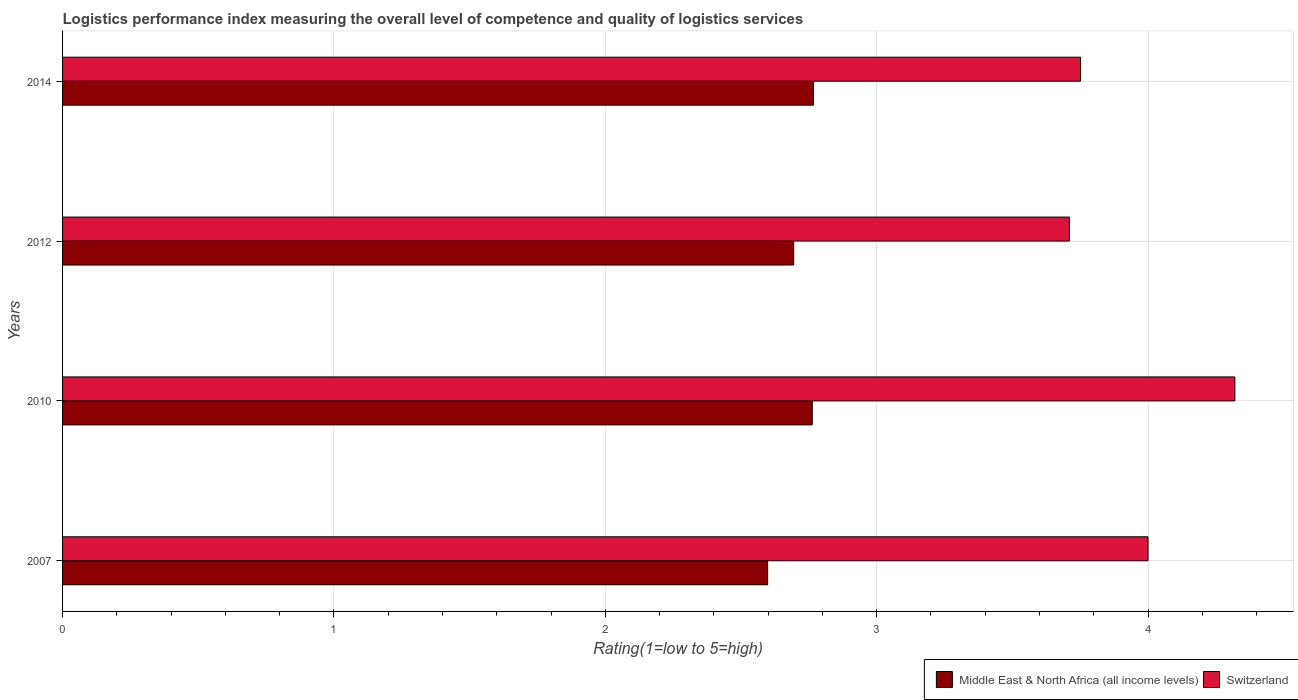Are the number of bars per tick equal to the number of legend labels?
Your answer should be compact. Yes. How many bars are there on the 3rd tick from the top?
Keep it short and to the point. 2. How many bars are there on the 3rd tick from the bottom?
Your response must be concise. 2. What is the label of the 2nd group of bars from the top?
Give a very brief answer. 2012. What is the Logistic performance index in Middle East & North Africa (all income levels) in 2010?
Provide a succinct answer. 2.76. Across all years, what is the maximum Logistic performance index in Switzerland?
Give a very brief answer. 4.32. Across all years, what is the minimum Logistic performance index in Switzerland?
Make the answer very short. 3.71. What is the total Logistic performance index in Switzerland in the graph?
Keep it short and to the point. 15.78. What is the difference between the Logistic performance index in Switzerland in 2007 and that in 2014?
Your response must be concise. 0.25. What is the difference between the Logistic performance index in Middle East & North Africa (all income levels) in 2014 and the Logistic performance index in Switzerland in 2007?
Provide a short and direct response. -1.23. What is the average Logistic performance index in Switzerland per year?
Offer a terse response. 3.95. In the year 2012, what is the difference between the Logistic performance index in Middle East & North Africa (all income levels) and Logistic performance index in Switzerland?
Give a very brief answer. -1.02. What is the ratio of the Logistic performance index in Middle East & North Africa (all income levels) in 2010 to that in 2012?
Give a very brief answer. 1.03. Is the difference between the Logistic performance index in Middle East & North Africa (all income levels) in 2007 and 2012 greater than the difference between the Logistic performance index in Switzerland in 2007 and 2012?
Offer a very short reply. No. What is the difference between the highest and the second highest Logistic performance index in Switzerland?
Offer a terse response. 0.32. What is the difference between the highest and the lowest Logistic performance index in Middle East & North Africa (all income levels)?
Offer a terse response. 0.17. Is the sum of the Logistic performance index in Middle East & North Africa (all income levels) in 2007 and 2012 greater than the maximum Logistic performance index in Switzerland across all years?
Provide a short and direct response. Yes. What does the 1st bar from the top in 2010 represents?
Make the answer very short. Switzerland. What does the 1st bar from the bottom in 2010 represents?
Ensure brevity in your answer.  Middle East & North Africa (all income levels). How many bars are there?
Offer a very short reply. 8. What is the difference between two consecutive major ticks on the X-axis?
Keep it short and to the point. 1. Are the values on the major ticks of X-axis written in scientific E-notation?
Give a very brief answer. No. Does the graph contain grids?
Keep it short and to the point. Yes. How many legend labels are there?
Ensure brevity in your answer.  2. How are the legend labels stacked?
Ensure brevity in your answer.  Horizontal. What is the title of the graph?
Make the answer very short. Logistics performance index measuring the overall level of competence and quality of logistics services. Does "Panama" appear as one of the legend labels in the graph?
Keep it short and to the point. No. What is the label or title of the X-axis?
Provide a succinct answer. Rating(1=low to 5=high). What is the Rating(1=low to 5=high) of Middle East & North Africa (all income levels) in 2007?
Keep it short and to the point. 2.6. What is the Rating(1=low to 5=high) of Middle East & North Africa (all income levels) in 2010?
Provide a short and direct response. 2.76. What is the Rating(1=low to 5=high) of Switzerland in 2010?
Keep it short and to the point. 4.32. What is the Rating(1=low to 5=high) of Middle East & North Africa (all income levels) in 2012?
Offer a very short reply. 2.69. What is the Rating(1=low to 5=high) in Switzerland in 2012?
Keep it short and to the point. 3.71. What is the Rating(1=low to 5=high) of Middle East & North Africa (all income levels) in 2014?
Make the answer very short. 2.77. What is the Rating(1=low to 5=high) in Switzerland in 2014?
Offer a terse response. 3.75. Across all years, what is the maximum Rating(1=low to 5=high) of Middle East & North Africa (all income levels)?
Your answer should be very brief. 2.77. Across all years, what is the maximum Rating(1=low to 5=high) of Switzerland?
Give a very brief answer. 4.32. Across all years, what is the minimum Rating(1=low to 5=high) of Middle East & North Africa (all income levels)?
Provide a succinct answer. 2.6. Across all years, what is the minimum Rating(1=low to 5=high) of Switzerland?
Your answer should be very brief. 3.71. What is the total Rating(1=low to 5=high) in Middle East & North Africa (all income levels) in the graph?
Offer a terse response. 10.82. What is the total Rating(1=low to 5=high) of Switzerland in the graph?
Your answer should be compact. 15.78. What is the difference between the Rating(1=low to 5=high) of Middle East & North Africa (all income levels) in 2007 and that in 2010?
Ensure brevity in your answer.  -0.16. What is the difference between the Rating(1=low to 5=high) of Switzerland in 2007 and that in 2010?
Offer a terse response. -0.32. What is the difference between the Rating(1=low to 5=high) of Middle East & North Africa (all income levels) in 2007 and that in 2012?
Offer a very short reply. -0.1. What is the difference between the Rating(1=low to 5=high) of Switzerland in 2007 and that in 2012?
Your answer should be compact. 0.29. What is the difference between the Rating(1=low to 5=high) of Middle East & North Africa (all income levels) in 2007 and that in 2014?
Provide a short and direct response. -0.17. What is the difference between the Rating(1=low to 5=high) in Switzerland in 2007 and that in 2014?
Provide a succinct answer. 0.25. What is the difference between the Rating(1=low to 5=high) in Middle East & North Africa (all income levels) in 2010 and that in 2012?
Your response must be concise. 0.07. What is the difference between the Rating(1=low to 5=high) of Switzerland in 2010 and that in 2012?
Your response must be concise. 0.61. What is the difference between the Rating(1=low to 5=high) of Middle East & North Africa (all income levels) in 2010 and that in 2014?
Your answer should be very brief. -0. What is the difference between the Rating(1=low to 5=high) of Switzerland in 2010 and that in 2014?
Ensure brevity in your answer.  0.57. What is the difference between the Rating(1=low to 5=high) in Middle East & North Africa (all income levels) in 2012 and that in 2014?
Offer a terse response. -0.07. What is the difference between the Rating(1=low to 5=high) of Switzerland in 2012 and that in 2014?
Provide a short and direct response. -0.04. What is the difference between the Rating(1=low to 5=high) of Middle East & North Africa (all income levels) in 2007 and the Rating(1=low to 5=high) of Switzerland in 2010?
Offer a very short reply. -1.72. What is the difference between the Rating(1=low to 5=high) in Middle East & North Africa (all income levels) in 2007 and the Rating(1=low to 5=high) in Switzerland in 2012?
Keep it short and to the point. -1.11. What is the difference between the Rating(1=low to 5=high) in Middle East & North Africa (all income levels) in 2007 and the Rating(1=low to 5=high) in Switzerland in 2014?
Offer a very short reply. -1.15. What is the difference between the Rating(1=low to 5=high) in Middle East & North Africa (all income levels) in 2010 and the Rating(1=low to 5=high) in Switzerland in 2012?
Keep it short and to the point. -0.95. What is the difference between the Rating(1=low to 5=high) of Middle East & North Africa (all income levels) in 2010 and the Rating(1=low to 5=high) of Switzerland in 2014?
Make the answer very short. -0.99. What is the difference between the Rating(1=low to 5=high) of Middle East & North Africa (all income levels) in 2012 and the Rating(1=low to 5=high) of Switzerland in 2014?
Provide a succinct answer. -1.06. What is the average Rating(1=low to 5=high) of Middle East & North Africa (all income levels) per year?
Give a very brief answer. 2.71. What is the average Rating(1=low to 5=high) of Switzerland per year?
Ensure brevity in your answer.  3.95. In the year 2007, what is the difference between the Rating(1=low to 5=high) of Middle East & North Africa (all income levels) and Rating(1=low to 5=high) of Switzerland?
Your response must be concise. -1.4. In the year 2010, what is the difference between the Rating(1=low to 5=high) of Middle East & North Africa (all income levels) and Rating(1=low to 5=high) of Switzerland?
Your answer should be compact. -1.56. In the year 2012, what is the difference between the Rating(1=low to 5=high) in Middle East & North Africa (all income levels) and Rating(1=low to 5=high) in Switzerland?
Give a very brief answer. -1.02. In the year 2014, what is the difference between the Rating(1=low to 5=high) of Middle East & North Africa (all income levels) and Rating(1=low to 5=high) of Switzerland?
Ensure brevity in your answer.  -0.98. What is the ratio of the Rating(1=low to 5=high) of Middle East & North Africa (all income levels) in 2007 to that in 2010?
Your answer should be very brief. 0.94. What is the ratio of the Rating(1=low to 5=high) of Switzerland in 2007 to that in 2010?
Your answer should be compact. 0.93. What is the ratio of the Rating(1=low to 5=high) of Middle East & North Africa (all income levels) in 2007 to that in 2012?
Ensure brevity in your answer.  0.96. What is the ratio of the Rating(1=low to 5=high) of Switzerland in 2007 to that in 2012?
Provide a succinct answer. 1.08. What is the ratio of the Rating(1=low to 5=high) in Middle East & North Africa (all income levels) in 2007 to that in 2014?
Offer a very short reply. 0.94. What is the ratio of the Rating(1=low to 5=high) of Switzerland in 2007 to that in 2014?
Give a very brief answer. 1.07. What is the ratio of the Rating(1=low to 5=high) in Middle East & North Africa (all income levels) in 2010 to that in 2012?
Make the answer very short. 1.03. What is the ratio of the Rating(1=low to 5=high) of Switzerland in 2010 to that in 2012?
Your answer should be compact. 1.16. What is the ratio of the Rating(1=low to 5=high) of Middle East & North Africa (all income levels) in 2010 to that in 2014?
Make the answer very short. 1. What is the ratio of the Rating(1=low to 5=high) of Switzerland in 2010 to that in 2014?
Give a very brief answer. 1.15. What is the ratio of the Rating(1=low to 5=high) of Middle East & North Africa (all income levels) in 2012 to that in 2014?
Make the answer very short. 0.97. What is the difference between the highest and the second highest Rating(1=low to 5=high) of Middle East & North Africa (all income levels)?
Your answer should be very brief. 0. What is the difference between the highest and the second highest Rating(1=low to 5=high) in Switzerland?
Provide a short and direct response. 0.32. What is the difference between the highest and the lowest Rating(1=low to 5=high) of Middle East & North Africa (all income levels)?
Offer a very short reply. 0.17. What is the difference between the highest and the lowest Rating(1=low to 5=high) of Switzerland?
Provide a short and direct response. 0.61. 